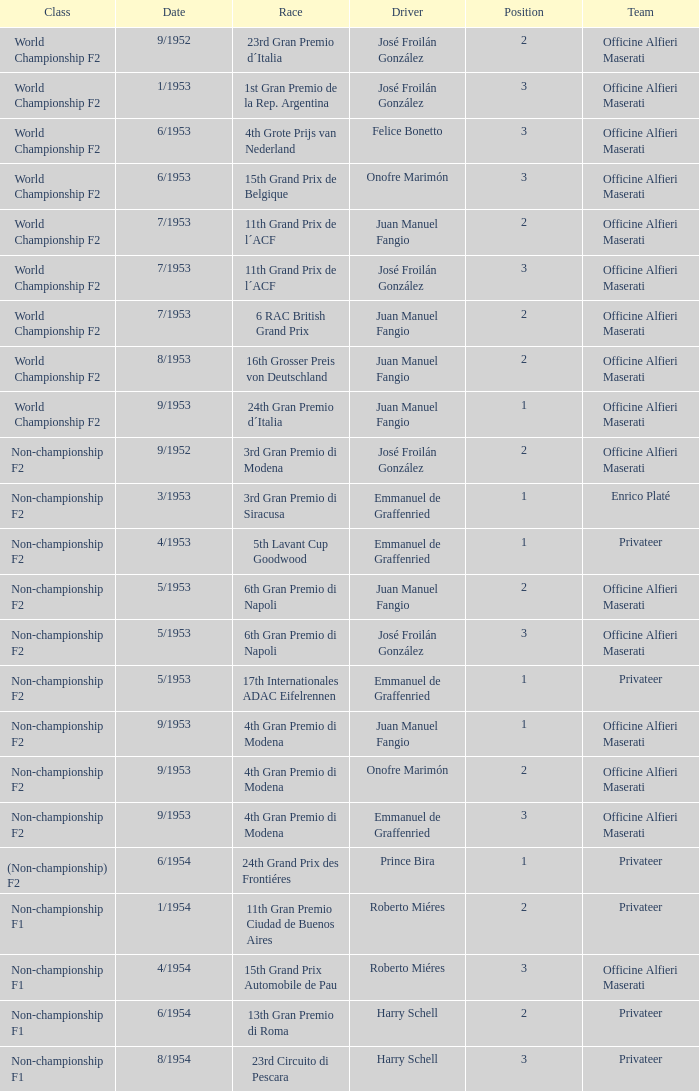Which team featured a driver called emmanuel de graffenried with a position higher than 1 in 9/1953? Officine Alfieri Maserati. Can you parse all the data within this table? {'header': ['Class', 'Date', 'Race', 'Driver', 'Position', 'Team'], 'rows': [['World Championship F2', '9/1952', '23rd Gran Premio d´Italia', 'José Froilán González', '2', 'Officine Alfieri Maserati'], ['World Championship F2', '1/1953', '1st Gran Premio de la Rep. Argentina', 'José Froilán González', '3', 'Officine Alfieri Maserati'], ['World Championship F2', '6/1953', '4th Grote Prijs van Nederland', 'Felice Bonetto', '3', 'Officine Alfieri Maserati'], ['World Championship F2', '6/1953', '15th Grand Prix de Belgique', 'Onofre Marimón', '3', 'Officine Alfieri Maserati'], ['World Championship F2', '7/1953', '11th Grand Prix de l´ACF', 'Juan Manuel Fangio', '2', 'Officine Alfieri Maserati'], ['World Championship F2', '7/1953', '11th Grand Prix de l´ACF', 'José Froilán González', '3', 'Officine Alfieri Maserati'], ['World Championship F2', '7/1953', '6 RAC British Grand Prix', 'Juan Manuel Fangio', '2', 'Officine Alfieri Maserati'], ['World Championship F2', '8/1953', '16th Grosser Preis von Deutschland', 'Juan Manuel Fangio', '2', 'Officine Alfieri Maserati'], ['World Championship F2', '9/1953', '24th Gran Premio d´Italia', 'Juan Manuel Fangio', '1', 'Officine Alfieri Maserati'], ['Non-championship F2', '9/1952', '3rd Gran Premio di Modena', 'José Froilán González', '2', 'Officine Alfieri Maserati'], ['Non-championship F2', '3/1953', '3rd Gran Premio di Siracusa', 'Emmanuel de Graffenried', '1', 'Enrico Platé'], ['Non-championship F2', '4/1953', '5th Lavant Cup Goodwood', 'Emmanuel de Graffenried', '1', 'Privateer'], ['Non-championship F2', '5/1953', '6th Gran Premio di Napoli', 'Juan Manuel Fangio', '2', 'Officine Alfieri Maserati'], ['Non-championship F2', '5/1953', '6th Gran Premio di Napoli', 'José Froilán González', '3', 'Officine Alfieri Maserati'], ['Non-championship F2', '5/1953', '17th Internationales ADAC Eifelrennen', 'Emmanuel de Graffenried', '1', 'Privateer'], ['Non-championship F2', '9/1953', '4th Gran Premio di Modena', 'Juan Manuel Fangio', '1', 'Officine Alfieri Maserati'], ['Non-championship F2', '9/1953', '4th Gran Premio di Modena', 'Onofre Marimón', '2', 'Officine Alfieri Maserati'], ['Non-championship F2', '9/1953', '4th Gran Premio di Modena', 'Emmanuel de Graffenried', '3', 'Officine Alfieri Maserati'], ['(Non-championship) F2', '6/1954', '24th Grand Prix des Frontiéres', 'Prince Bira', '1', 'Privateer'], ['Non-championship F1', '1/1954', '11th Gran Premio Ciudad de Buenos Aires', 'Roberto Miéres', '2', 'Privateer'], ['Non-championship F1', '4/1954', '15th Grand Prix Automobile de Pau', 'Roberto Miéres', '3', 'Officine Alfieri Maserati'], ['Non-championship F1', '6/1954', '13th Gran Premio di Roma', 'Harry Schell', '2', 'Privateer'], ['Non-championship F1', '8/1954', '23rd Circuito di Pescara', 'Harry Schell', '3', 'Privateer']]} 